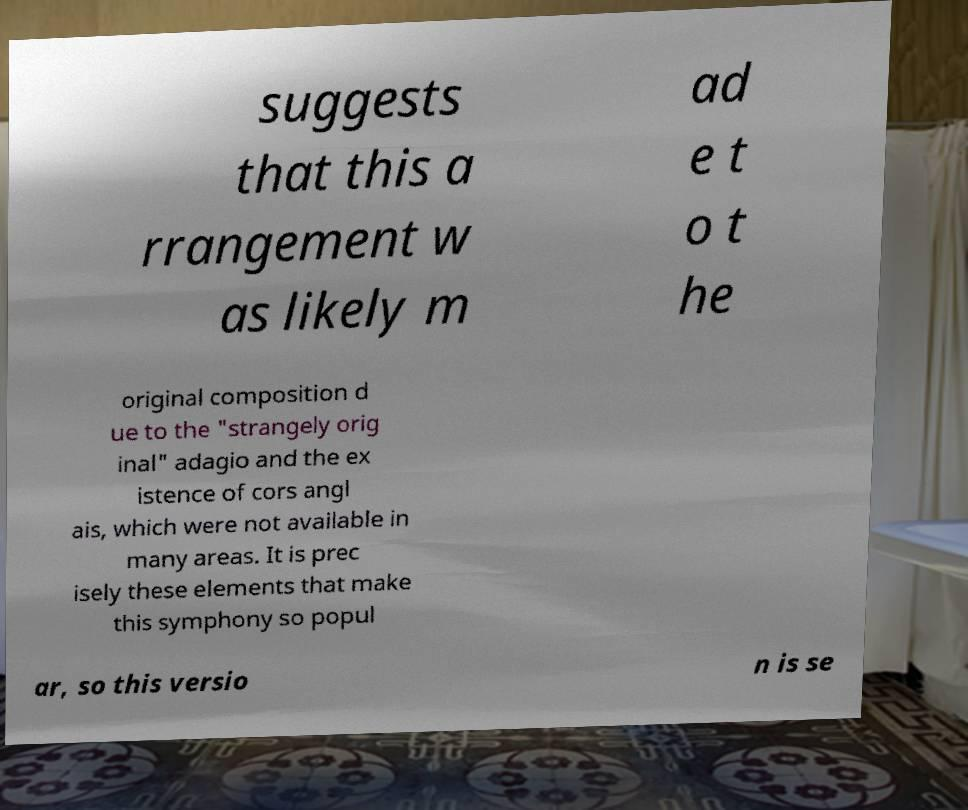What messages or text are displayed in this image? I need them in a readable, typed format. suggests that this a rrangement w as likely m ad e t o t he original composition d ue to the "strangely orig inal" adagio and the ex istence of cors angl ais, which were not available in many areas. It is prec isely these elements that make this symphony so popul ar, so this versio n is se 